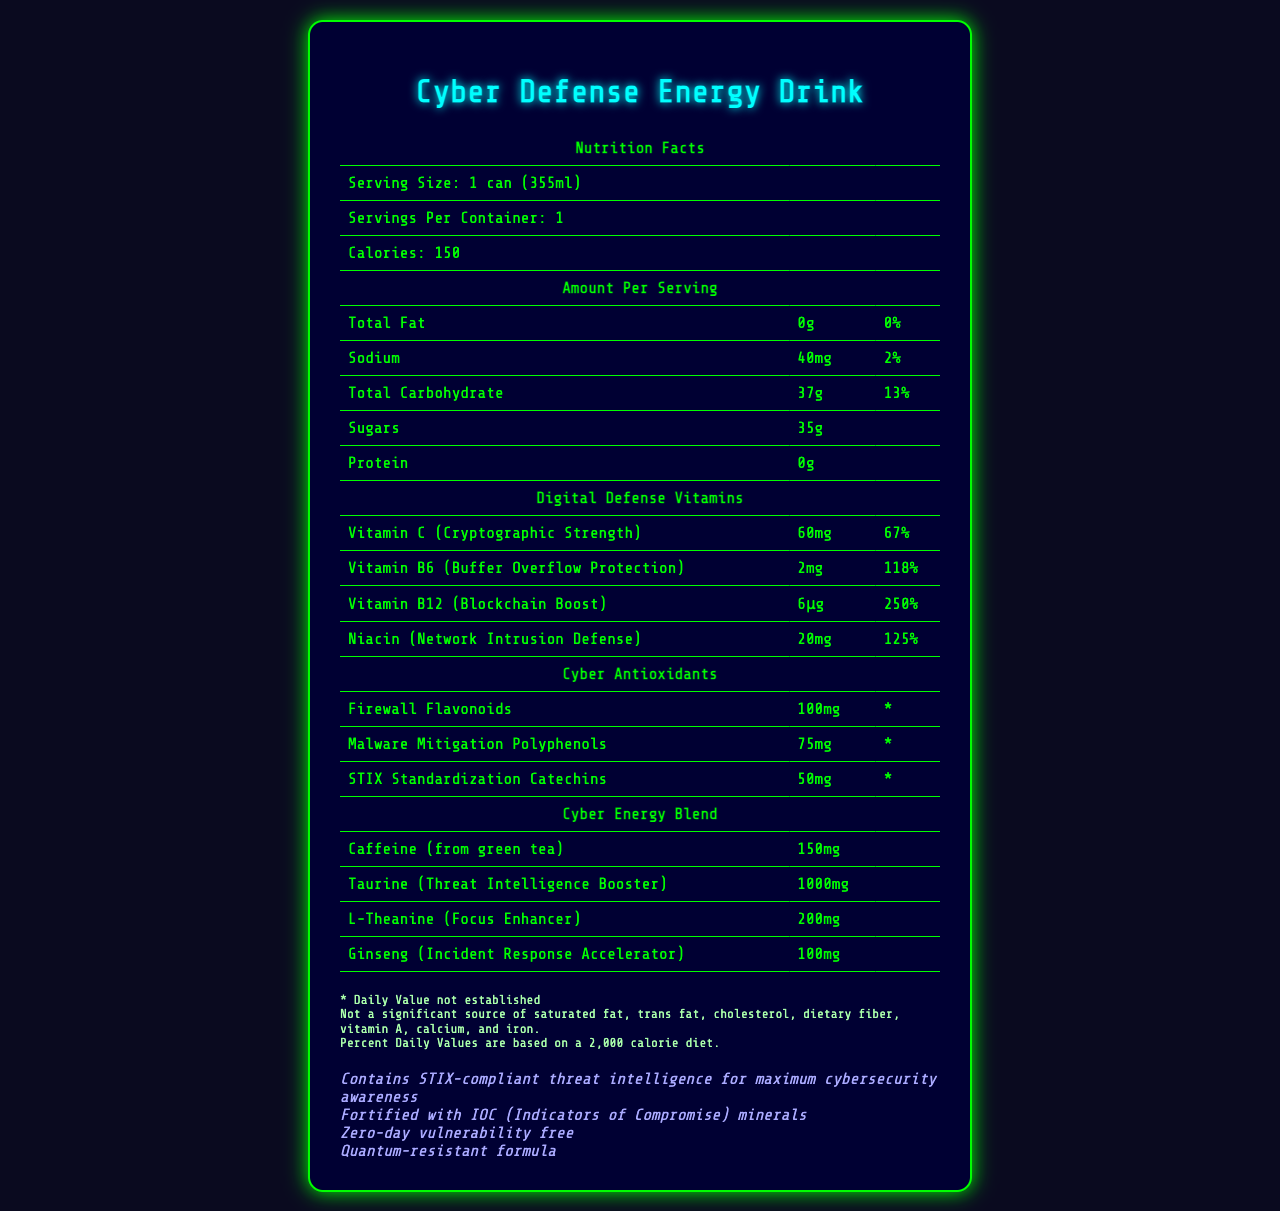what is the serving size of the Cyber Defense Energy Drink? The serving size is stated in the document under "Serving Size: 1 can (355ml)".
Answer: 1 can (355ml) how many servings are in one container of the Cyber Defense Energy Drink? The document lists "Servings Per Container: 1".
Answer: 1 how many calories does one serving of the Cyber Defense Energy Drink contain? The document shows "Calories: 150" under the serving information.
Answer: 150 what is the amount of Vitamin B12 (Blockchain Boost) in the Cyber Defense Energy Drink? The document presents "Vitamin B12 (Blockchain Boost): 6μg" under the section "Digital Defense Vitamins".
Answer: 6μg how much Caffeine (from green tea) does the Cyber Defense Energy Drink include? The document includes Caffeine information under the "Cyber Energy Blend" section and lists "Caffeine (from green tea): 150mg".
Answer: 150mg what percentage of the daily value of Niacin (Network Intrusion Defense) does the drink provide? A. 67% B. 118% C. 125% D. 250% The drink provides 125% of the daily value for Niacin, as stated in the document under "Digital Defense Vitamins".
Answer: C what is the amount of Malware Mitigation Polyphenols in the drink? A. 50mg B. 75mg C. 100mg D. 125mg The document lists "Malware Mitigation Polyphenols: 75mg" under the "Cyber Antioxidants" section.
Answer: B is the Cyber Defense Energy Drink a significant source of dietary fiber? A disclaimer in the document states that the drink is "Not a significant source of saturated fat, trans fat, cholesterol, dietary fiber, vitamin A, calcium, and iron."
Answer: No does the drink contain any saturated fat? The amount of Total Fat is listed as "0g" in the document, which includes saturated fat.
Answer: No what unique features are highlighted about the Cyber Defense Energy Drink? The additional information section of the document highlights these features.
Answer: STIX-compliant threat intelligence, IOC minerals, zero-day vulnerability free, quantum-resistant formula how much Sodium is in the Cyber Defense Energy Drink compared to the daily requirement? The document indicates that the drink contains 40mg of Sodium, which is 2% of the daily value.
Answer: 40mg, 2% how much sugar does the Cyber Defense Energy Drink contain? The document lists "Sugars: 35g" under the nutrients section.
Answer: 35g describe the overall contents and theme of the Cyber Defense Energy Drink's Nutrition Facts Label. The document blends standard nutritional data with cybersecurity-themed vitamins and ingredients, emphasizing its role in digital defense and cyber awareness. Disclaimers and additional information provide context about daily values and unique attributes.
Answer: The label provides detailed nutritional information, including serving size, calories, and amounts of fats, sodium, carbohydrates, sugars, and proteins. It also highlights unique digital defense vitamins and cyber antioxidants, such as "Vitamin C (Cryptographic Strength)" and "Firewall Flavonoids." Additionally, it includes a cyber energy blend with ingredients like Caffeine and Ginseng. Extra information emphasizes its cybersecurity-related features and disclaimers about the daily values and nutrient sources. does the Cyber Defense Energy Drink contain indicators of compromise (IOC) minerals? The additional information section mentions that the drink is "Fortified with IOC (Indicators of Compromise) minerals."
Answer: Yes how much L-Theanine (Focus Enhancer) is in the Cyber Defense Energy Drink? The document specifies "L-Theanine (Focus Enhancer): 200mg" under the "Cyber Energy Blend" section.
Answer: 200mg which antioxidant amount is 50mg in the Cyber Defense Energy Drink? The document lists "STIX Standardization Catechins: 50mg" under the "Cyber Antioxidants" section.
Answer: STIX Standardization Catechins what is the amount of Vitamin C (Cryptographic Strength) compared to the daily value? The document states that the drink contains 60mg of Vitamin C, which is 67% of the daily value.
Answer: 60mg, 67% how much protein does the Cyber Defense Energy Drink include? The document lists "Protein: 0g" under the nutrients section.
Answer: 0g what specific mineral or vitamin content is quantum-resistant? The document does not specify which minerals or vitamins are quantum-resistant, only that the formula as a whole has this quality in the additional information section.
Answer: Not enough information 